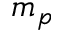<formula> <loc_0><loc_0><loc_500><loc_500>m _ { p }</formula> 